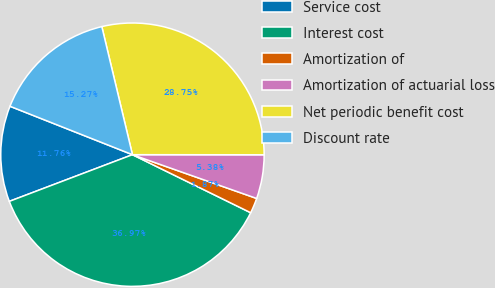Convert chart. <chart><loc_0><loc_0><loc_500><loc_500><pie_chart><fcel>Service cost<fcel>Interest cost<fcel>Amortization of<fcel>Amortization of actuarial loss<fcel>Net periodic benefit cost<fcel>Discount rate<nl><fcel>11.76%<fcel>36.97%<fcel>1.87%<fcel>5.38%<fcel>28.75%<fcel>15.27%<nl></chart> 